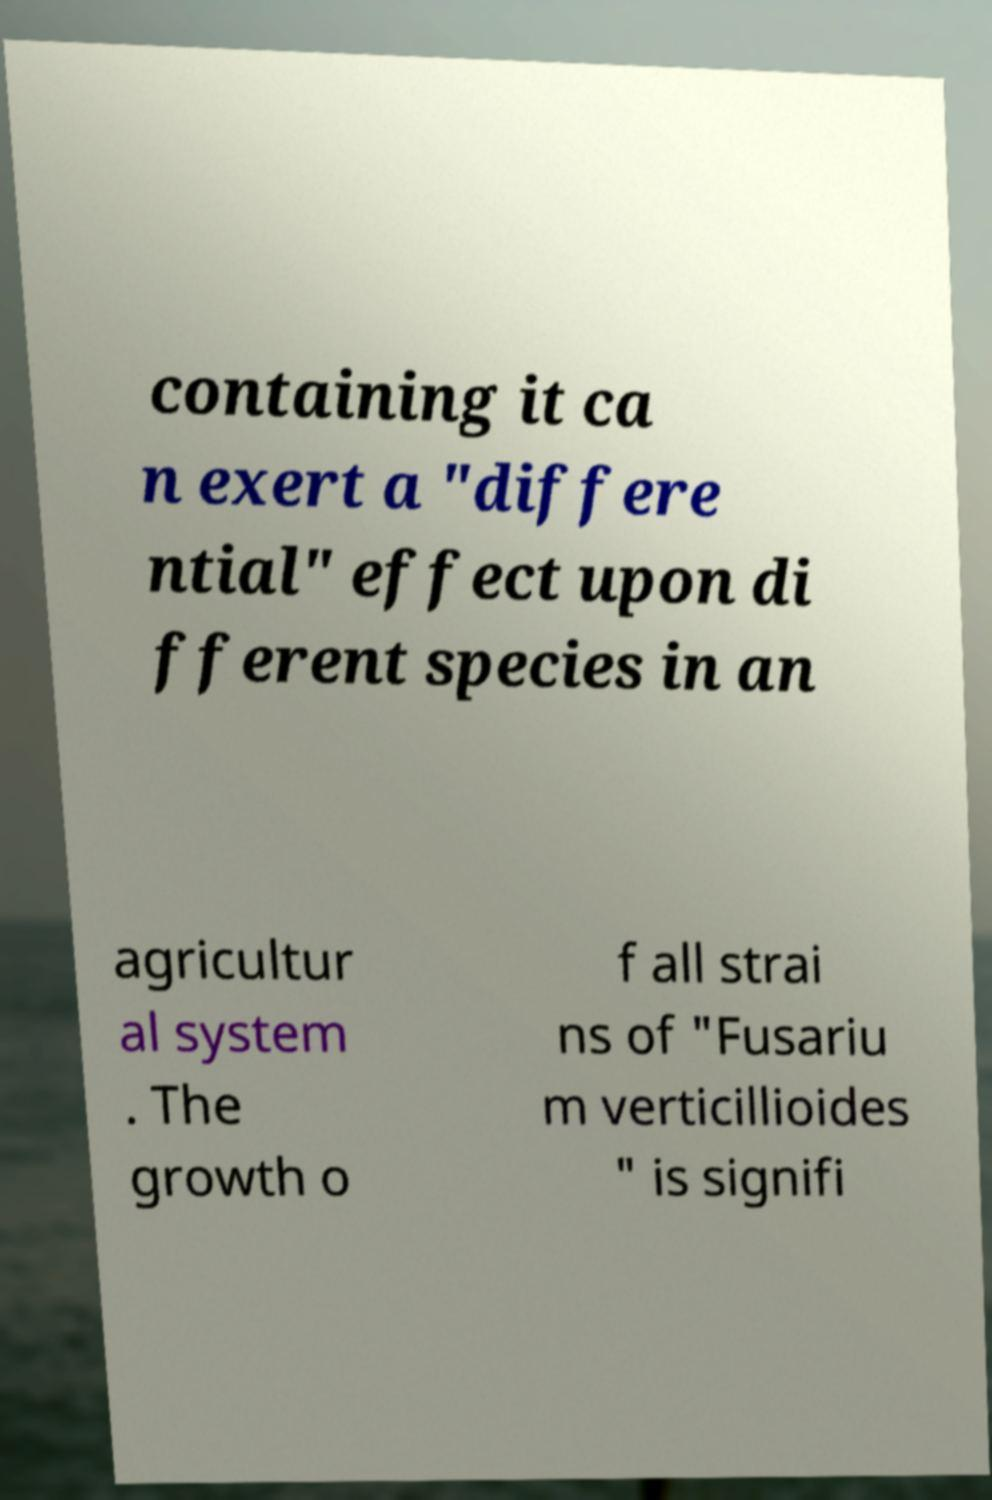Could you extract and type out the text from this image? containing it ca n exert a "differe ntial" effect upon di fferent species in an agricultur al system . The growth o f all strai ns of "Fusariu m verticillioides " is signifi 